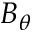Convert formula to latex. <formula><loc_0><loc_0><loc_500><loc_500>B _ { \theta }</formula> 